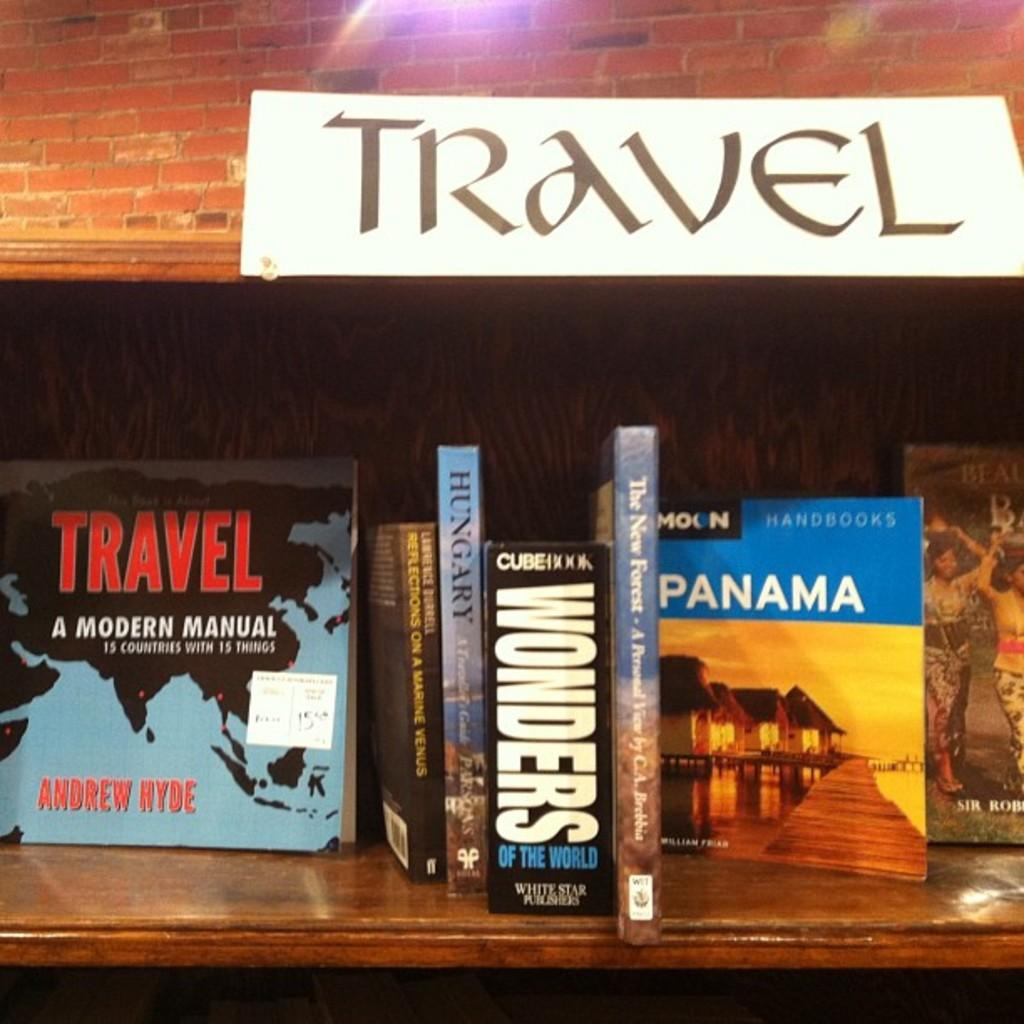Provide a one-sentence caption for the provided image. Books about travel including one about Panama and Hungary are sitting on a shelf. 